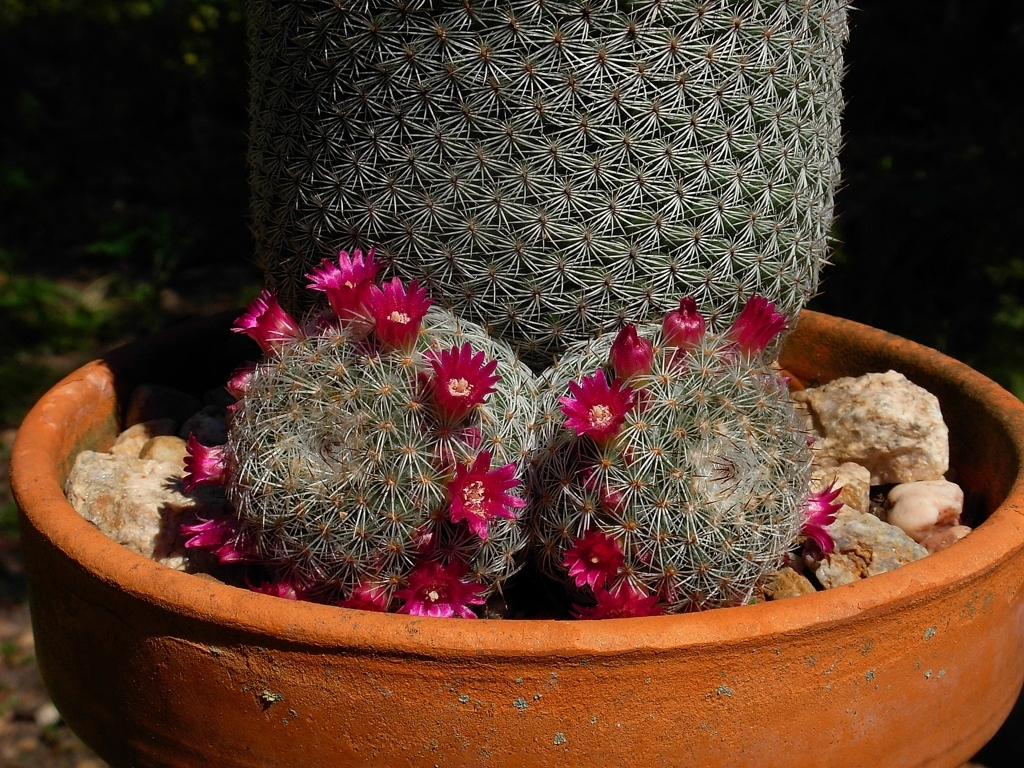What kind of environment is suitable for this cactus to thrive? This cactus prefers a dry, arid environment with plenty of sunlight. It's adapted to thrive in conditions where water is scarce, hence the spines which minimize water loss and fleshy tissues for water storage. 